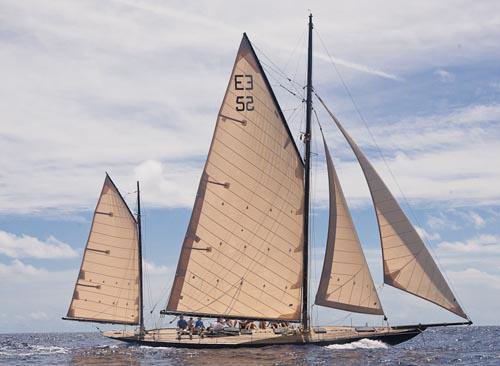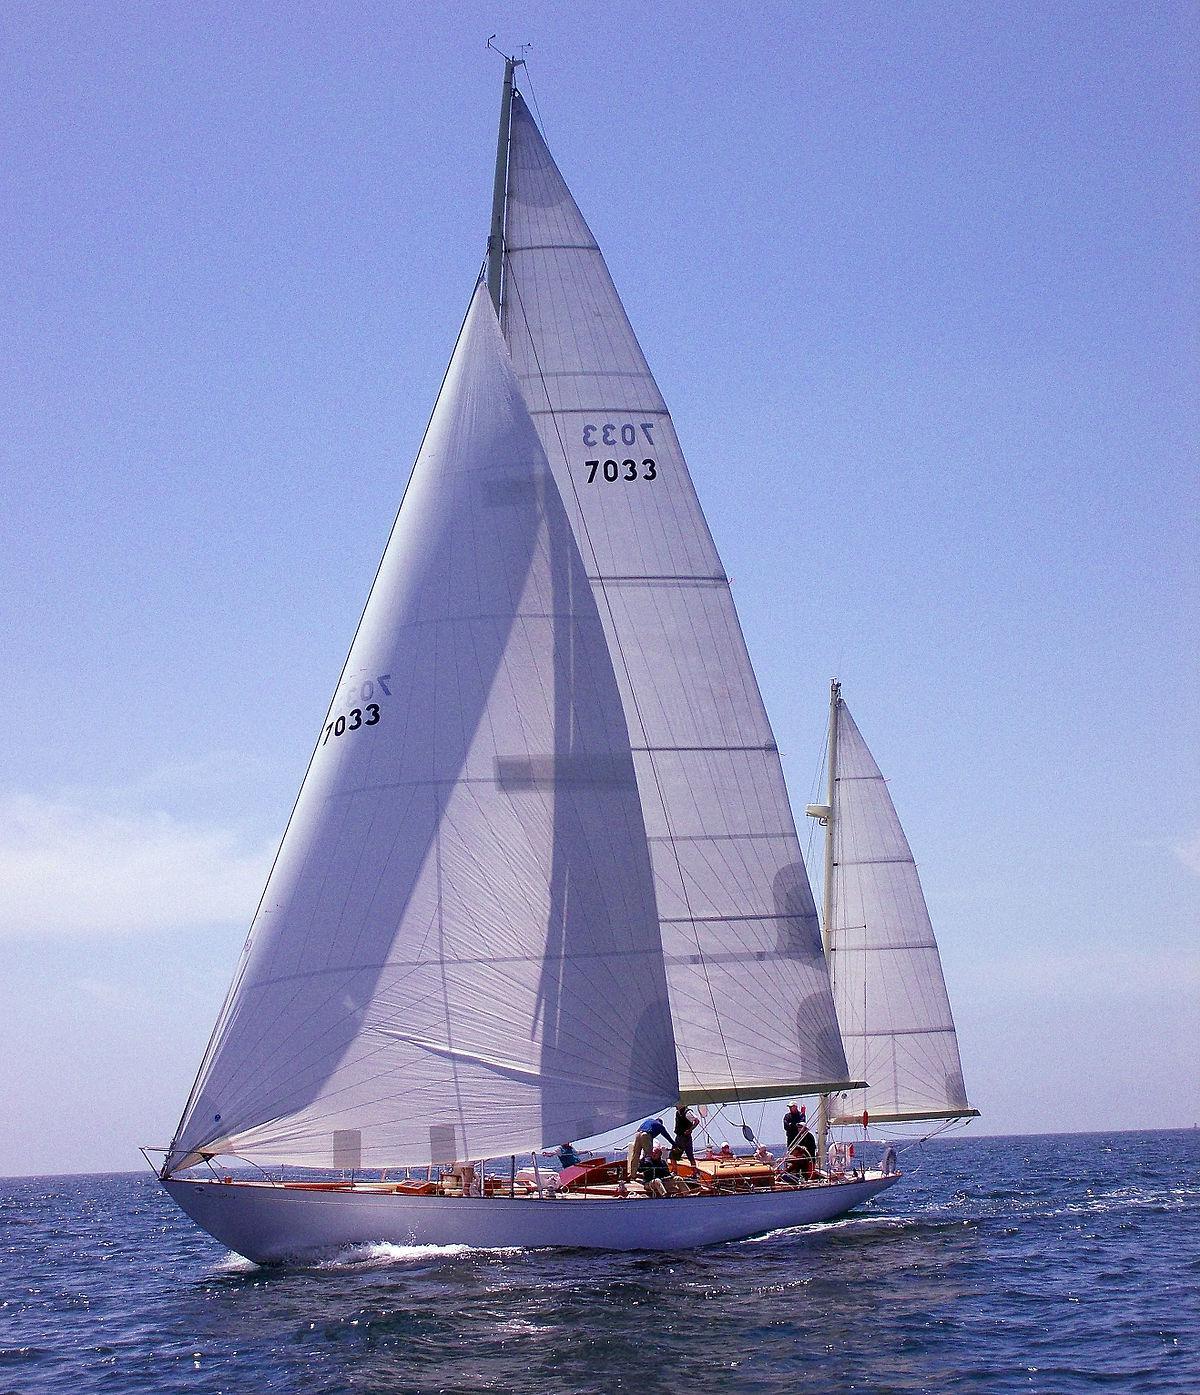The first image is the image on the left, the second image is the image on the right. For the images displayed, is the sentence "One of the images features a sailboat with its sails furled" factually correct? Answer yes or no. No. 